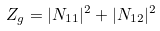Convert formula to latex. <formula><loc_0><loc_0><loc_500><loc_500>Z _ { g } = | N _ { 1 1 } | ^ { 2 } + | N _ { 1 2 } | ^ { 2 }</formula> 